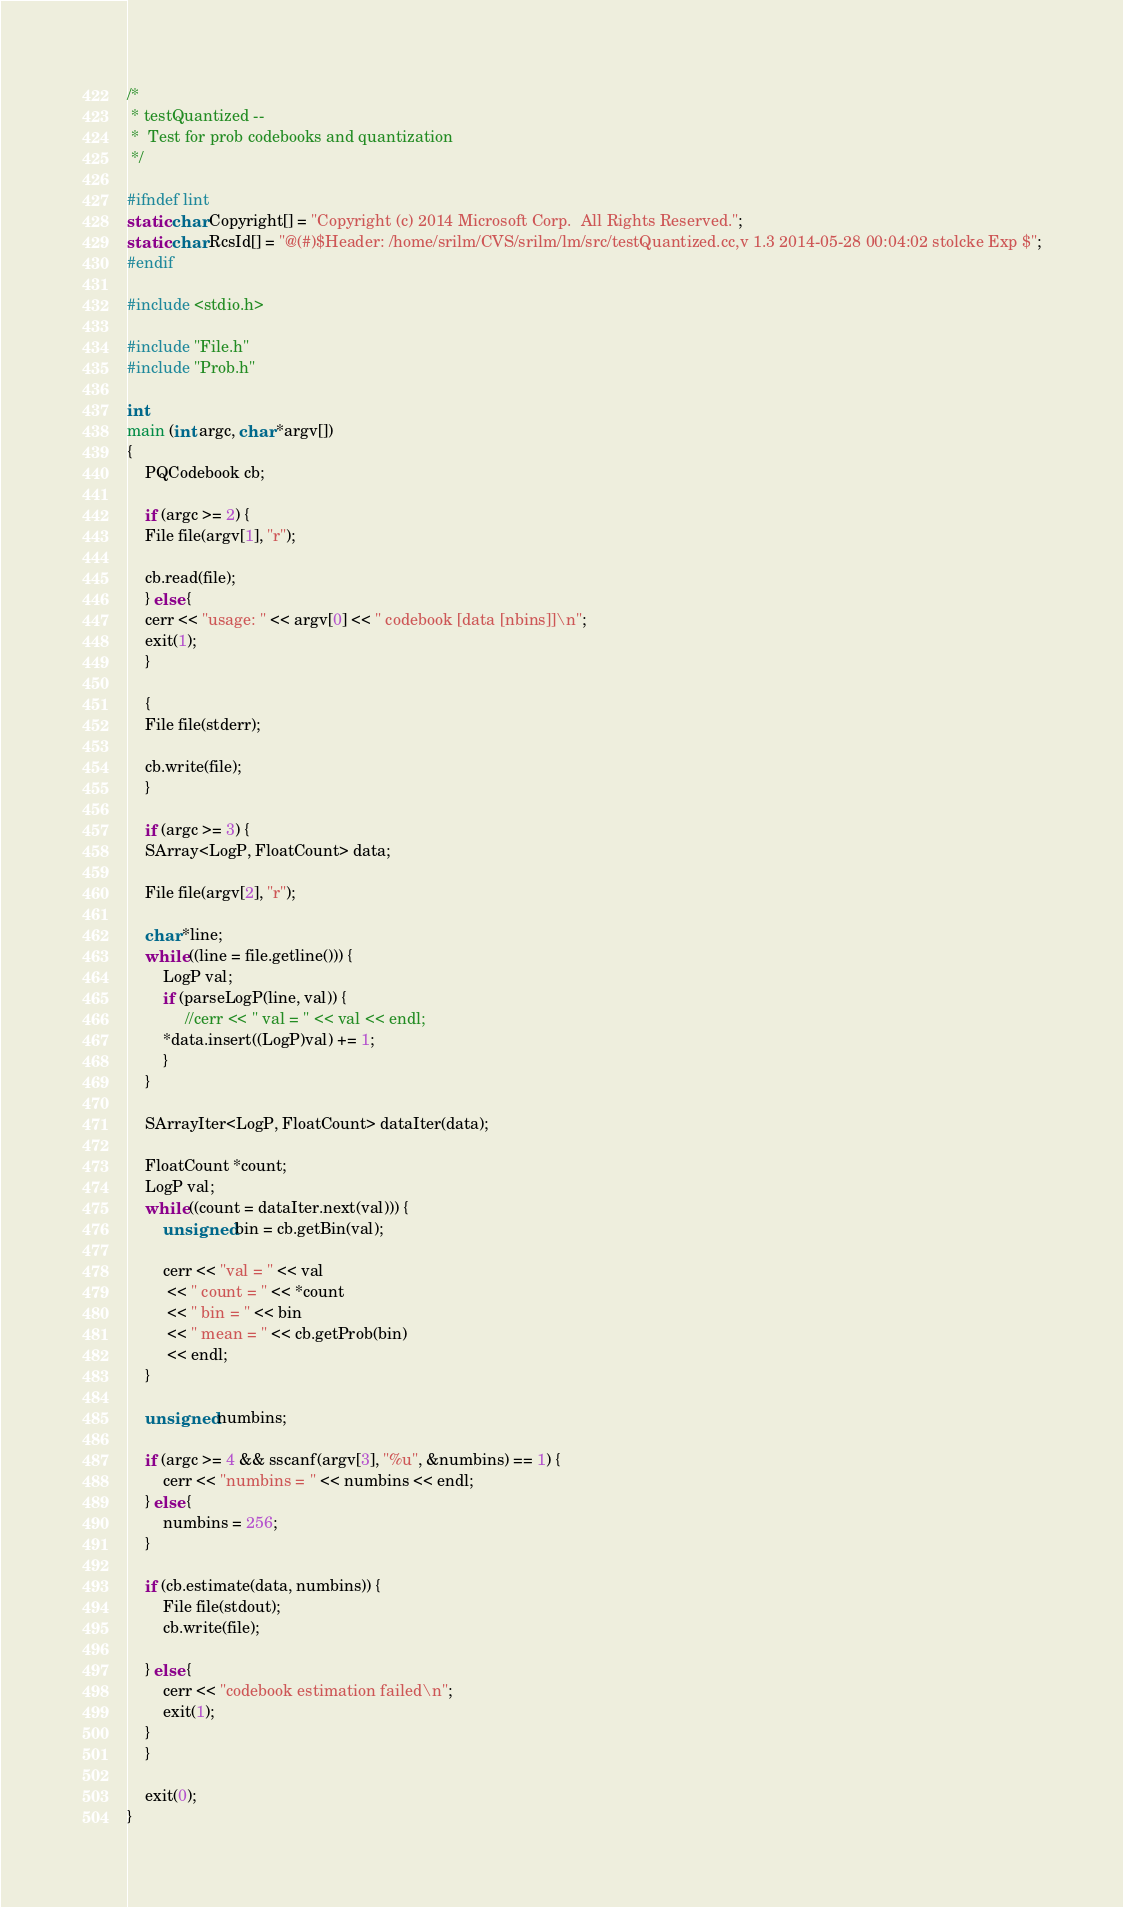<code> <loc_0><loc_0><loc_500><loc_500><_C++_>/*
 * testQuantized --
 *	Test for prob codebooks and quantization
 */

#ifndef lint
static char Copyright[] = "Copyright (c) 2014 Microsoft Corp.  All Rights Reserved.";
static char RcsId[] = "@(#)$Header: /home/srilm/CVS/srilm/lm/src/testQuantized.cc,v 1.3 2014-05-28 00:04:02 stolcke Exp $";
#endif

#include <stdio.h>

#include "File.h"
#include "Prob.h"

int
main (int argc, char *argv[])
{
    PQCodebook cb;

    if (argc >= 2) {
	File file(argv[1], "r");

	cb.read(file);
    } else {
	cerr << "usage: " << argv[0] << " codebook [data [nbins]]\n";
	exit(1);
    }

    {
	File file(stderr);

	cb.write(file);
    }

    if (argc >= 3) {
	SArray<LogP, FloatCount> data;

	File file(argv[2], "r");

	char *line;
	while ((line = file.getline())) {
	    LogP val;
	    if (parseLogP(line, val)) {
	         //cerr << " val = " << val << endl;
		*data.insert((LogP)val) += 1;
	    }
	}

	SArrayIter<LogP, FloatCount> dataIter(data);

	FloatCount *count;
	LogP val;
	while ((count = dataIter.next(val))) {
	    unsigned bin = cb.getBin(val);

	    cerr << "val = " << val
		 << " count = " << *count
		 << " bin = " << bin
		 << " mean = " << cb.getProb(bin)
		 << endl;
	}

	unsigned numbins;

	if (argc >= 4 && sscanf(argv[3], "%u", &numbins) == 1) {
	    cerr << "numbins = " << numbins << endl;
	} else {
	    numbins = 256;
	}

	if (cb.estimate(data, numbins)) {
	    File file(stdout);
	    cb.write(file);

	} else {
	    cerr << "codebook estimation failed\n";
	    exit(1);
	}
    }

    exit(0);
}
</code> 